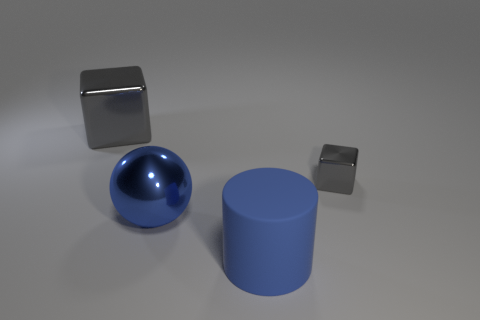What shape is the large metallic object that is the same color as the small metal object?
Make the answer very short. Cube. Is there anything else that has the same color as the rubber object?
Provide a succinct answer. Yes. What is the material of the big thing that is the same shape as the small gray metal object?
Give a very brief answer. Metal. Are there any other things that have the same material as the big cylinder?
Your answer should be compact. No. Is the material of the cube that is behind the tiny gray metal thing the same as the thing that is right of the large blue matte thing?
Your response must be concise. Yes. What color is the cube that is in front of the large cube to the left of the gray block that is in front of the large gray cube?
Give a very brief answer. Gray. What number of other things are the same shape as the large blue matte object?
Ensure brevity in your answer.  0. Is the color of the matte thing the same as the big metal ball?
Give a very brief answer. Yes. How many objects are large purple rubber cylinders or gray blocks that are behind the tiny shiny object?
Ensure brevity in your answer.  1. Are there any cylinders that have the same size as the blue sphere?
Provide a short and direct response. Yes. 